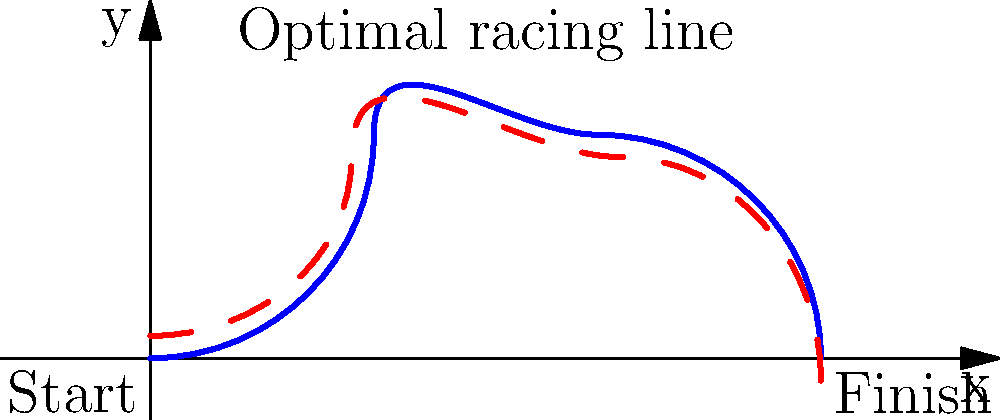As an experienced racing journalist, you're analyzing the optimal racing line through a series of corners on a track. The track layout can be approximated by the parametric equations:

$$x(t) = 2t$$
$$y(t) = 2\sin(\pi t/2)$$

where $0 \leq t \leq 3$. If a driver wants to maximize their exit speed from the final corner, at approximately what x-coordinate should they apex the last turn? To determine the optimal racing line and the apex of the last turn, we need to follow these steps:

1) First, let's understand what the parametric equations represent:
   - $x(t) = 2t$ means the x-coordinate increases linearly with t
   - $y(t) = 2\sin(\pi t/2)$ represents the curvature of the track

2) The last turn begins where the track starts to curve downward. This occurs when the sine function reaches its maximum value, which is at $t = 1$.

3) At $t = 1$:
   $x(1) = 2(1) = 2$
   $y(1) = 2\sin(\pi/2) = 2$

4) The apex of a turn is the point where the racing line comes closest to the inside of the corner. For the last turn, this should be slightly past the midpoint of the turn.

5) The midpoint of the last turn is at $t = 2$ (halfway between $t = 1$ and $t = 3$):
   $x(2) = 2(2) = 4$
   $y(2) = 2\sin(\pi) = 0$

6) The optimal apex should be slightly after this midpoint, approximately at $t = 2.2$:
   $x(2.2) = 2(2.2) = 4.4$

7) Therefore, the optimal apex of the last turn should be at approximately x = 4.4.

This racing line allows the driver to straighten the corner as much as possible, carrying more speed through the turn and maximizing exit speed.
Answer: x ≈ 4.4 